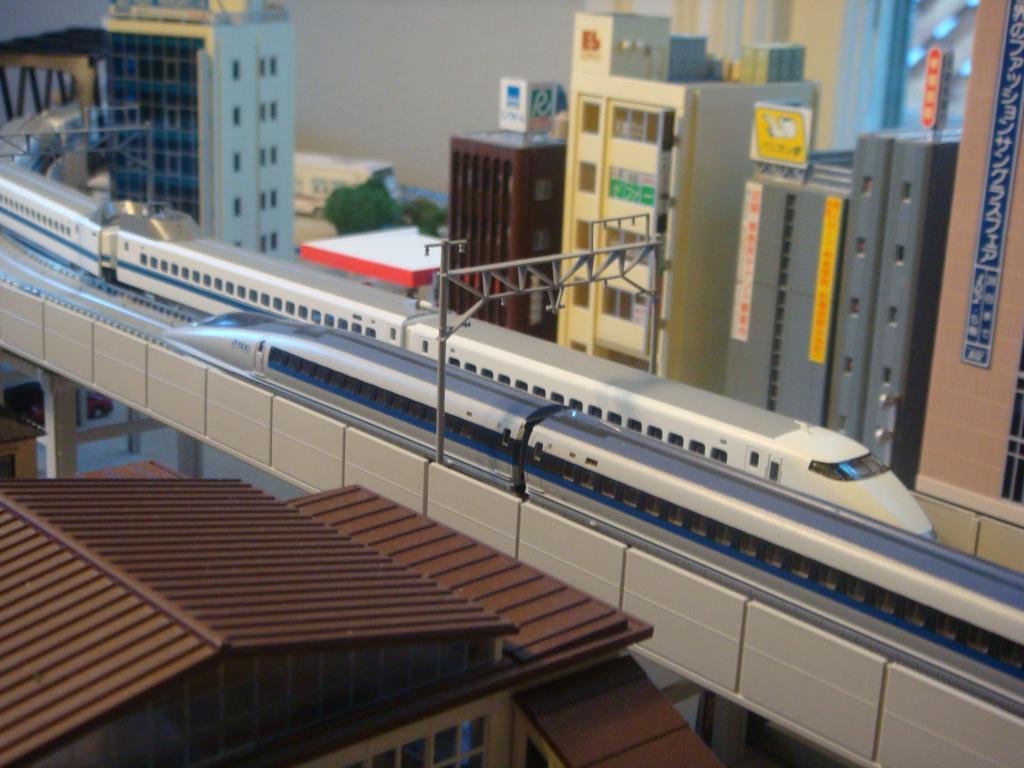Please provide a concise description of this image. In this image we can see the buildings and also roof house. We can also see the bridge, poles and trains passing on the railway track. We can also see the trees. 